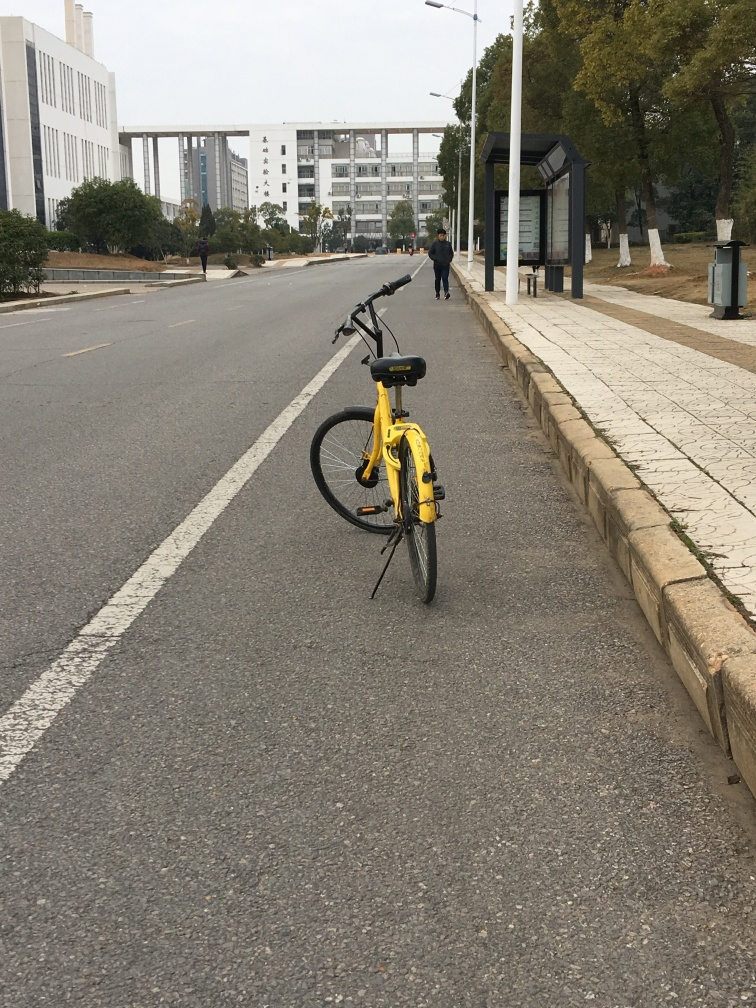What time of day and season does this image suggest? The overcast sky and the absence of shadows suggest that it could be either early morning or late afternoon, while the attire of the pedestrians hints at a cooler season, but not necessarily winter. The lack of leaves on the trees also suggests it might be autumn or late fall. 